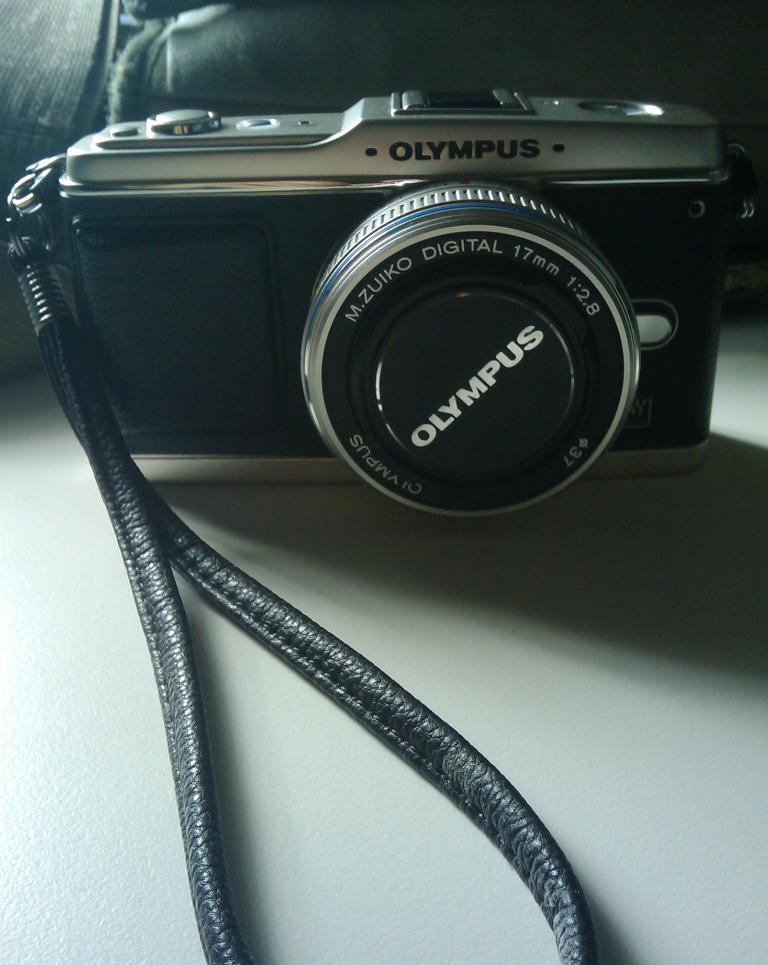Can you describe this image briefly? In this picture I can see the camera and bag which is kept on the table. In the top right corner I can see the darkness. 